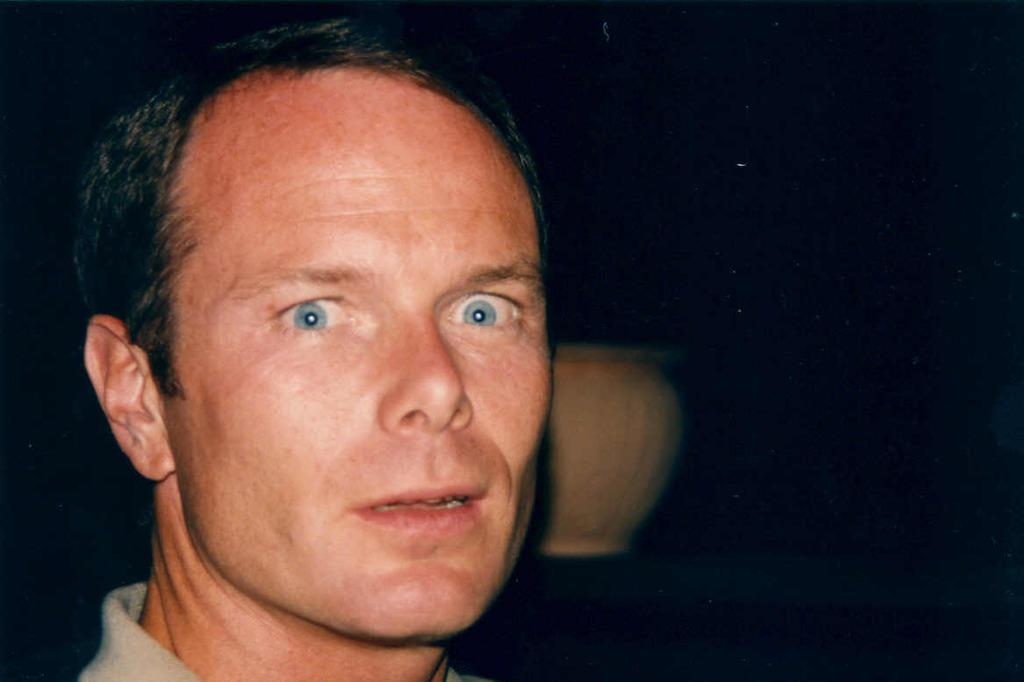Who is present in the image? There is a man in the image. What can be seen in the background of the image? There is a pot in the background of the image. How would you describe the lighting in the image? The background of the image is dark. How many birds are in the flock that is flying through the door in the image? There is no flock of birds or door present in the image. 